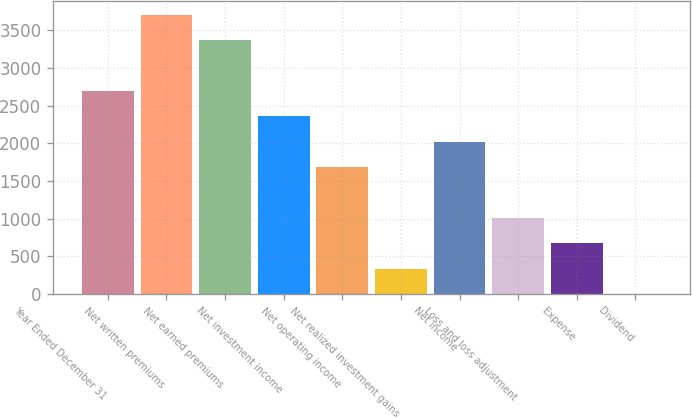<chart> <loc_0><loc_0><loc_500><loc_500><bar_chart><fcel>Year Ended December 31<fcel>Net written premiums<fcel>Net earned premiums<fcel>Net investment income<fcel>Net operating income<fcel>Net realized investment gains<fcel>Net income<fcel>Loss and loss adjustment<fcel>Expense<fcel>Dividend<nl><fcel>2697.62<fcel>3704.19<fcel>3367<fcel>2360.43<fcel>1686.05<fcel>337.29<fcel>2023.24<fcel>1011.67<fcel>674.48<fcel>0.1<nl></chart> 